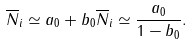<formula> <loc_0><loc_0><loc_500><loc_500>\overline { N } _ { i } \simeq a _ { 0 } + b _ { 0 } \overline { N } _ { i } \simeq \frac { a _ { 0 } } { 1 - b _ { 0 } } .</formula> 